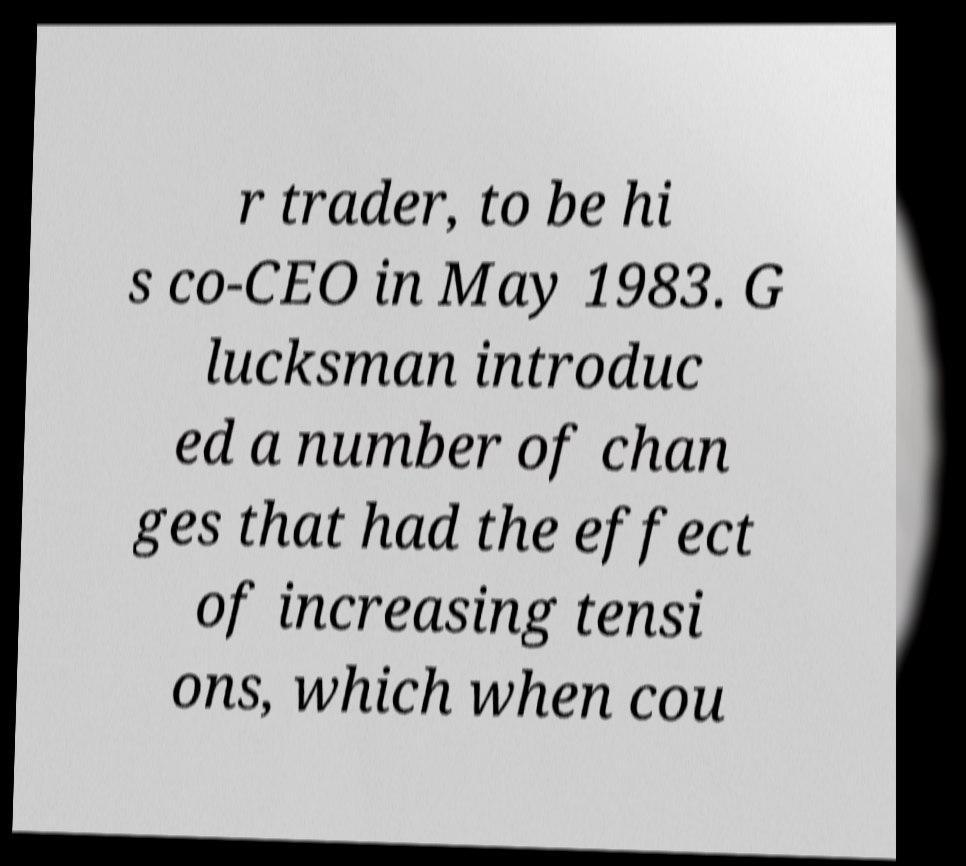Please read and relay the text visible in this image. What does it say? r trader, to be hi s co-CEO in May 1983. G lucksman introduc ed a number of chan ges that had the effect of increasing tensi ons, which when cou 